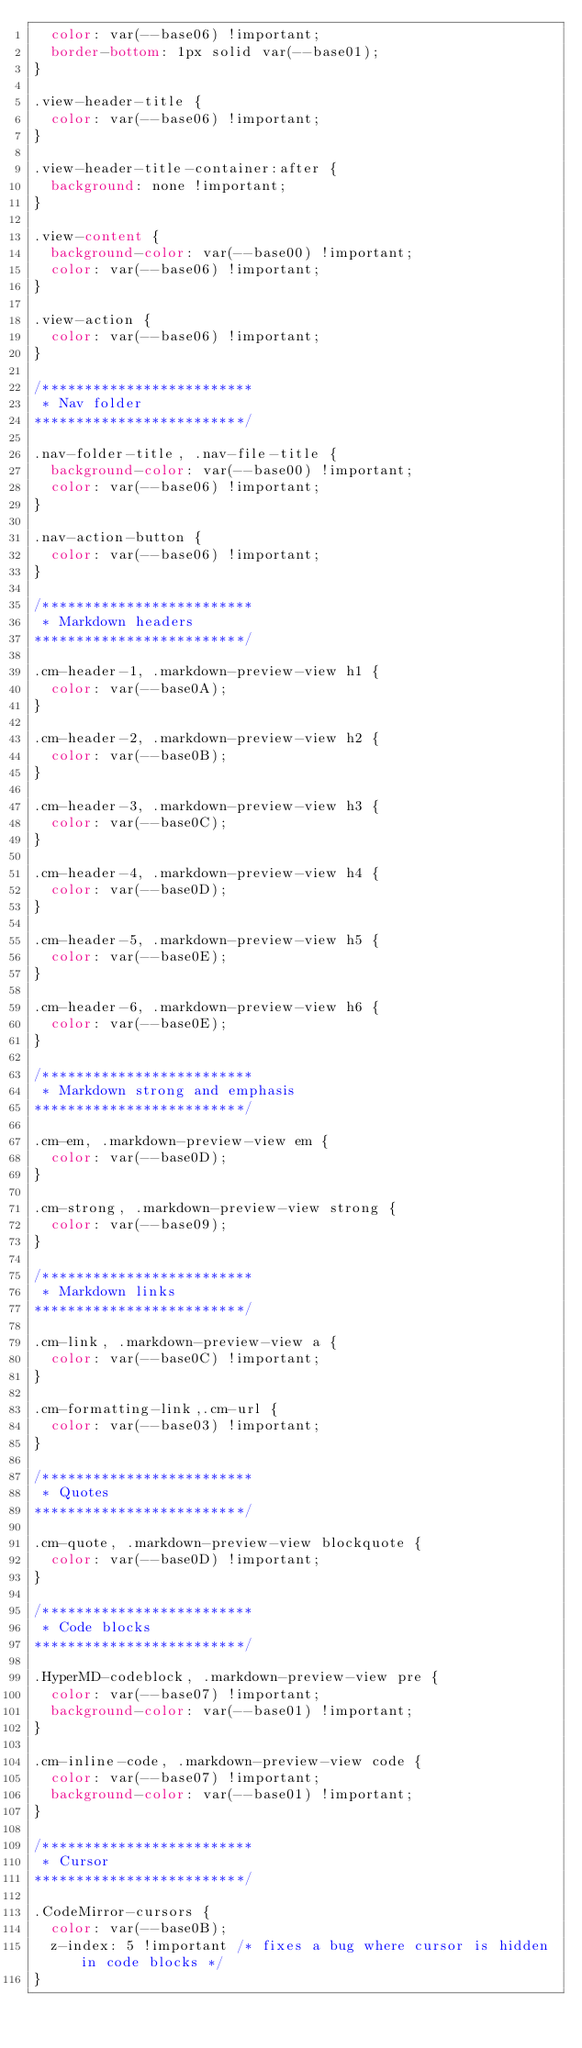Convert code to text. <code><loc_0><loc_0><loc_500><loc_500><_CSS_>  color: var(--base06) !important;
  border-bottom: 1px solid var(--base01);
}

.view-header-title {
  color: var(--base06) !important;
}

.view-header-title-container:after {
  background: none !important;
}

.view-content {
  background-color: var(--base00) !important;
  color: var(--base06) !important;
}

.view-action {
  color: var(--base06) !important;
}

/*************************
 * Nav folder
*************************/

.nav-folder-title, .nav-file-title {
  background-color: var(--base00) !important;
  color: var(--base06) !important;
}

.nav-action-button {
  color: var(--base06) !important;
}

/*************************
 * Markdown headers
*************************/

.cm-header-1, .markdown-preview-view h1 {
  color: var(--base0A);
}

.cm-header-2, .markdown-preview-view h2 {
  color: var(--base0B);
}

.cm-header-3, .markdown-preview-view h3 {
  color: var(--base0C);
}

.cm-header-4, .markdown-preview-view h4 {
  color: var(--base0D);
}

.cm-header-5, .markdown-preview-view h5 {
  color: var(--base0E);
}

.cm-header-6, .markdown-preview-view h6 {
  color: var(--base0E);
}

/*************************
 * Markdown strong and emphasis
*************************/

.cm-em, .markdown-preview-view em {
  color: var(--base0D);
}

.cm-strong, .markdown-preview-view strong {
  color: var(--base09);
}

/*************************
 * Markdown links
*************************/

.cm-link, .markdown-preview-view a {
  color: var(--base0C) !important;
}

.cm-formatting-link,.cm-url {
  color: var(--base03) !important;
}

/*************************
 * Quotes
*************************/

.cm-quote, .markdown-preview-view blockquote {
  color: var(--base0D) !important;
}

/*************************
 * Code blocks
*************************/

.HyperMD-codeblock, .markdown-preview-view pre {
  color: var(--base07) !important;
  background-color: var(--base01) !important;
}

.cm-inline-code, .markdown-preview-view code {
  color: var(--base07) !important;
  background-color: var(--base01) !important;
}

/*************************
 * Cursor
*************************/

.CodeMirror-cursors {
  color: var(--base0B);
  z-index: 5 !important /* fixes a bug where cursor is hidden in code blocks */
}
</code> 